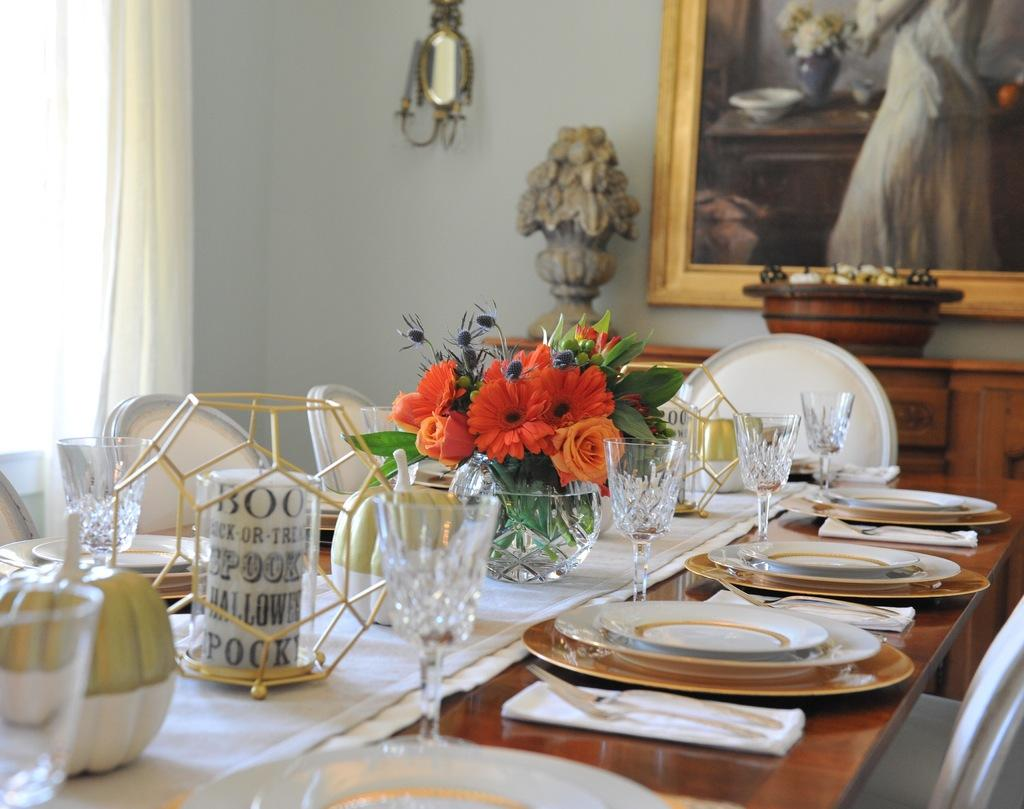What piece of furniture is present in the image? There is a table in the image. What items can be seen on the table? There are plates and glasses on the table, as well as other objects. What is the purpose of the curtain in the image? The curtain is likely used for privacy or to control light in the room. Where is the photo located in the image? The photo is on a wall in the image. What advice does the committee give in the image? There is no committee present in the image, so no advice can be given. 